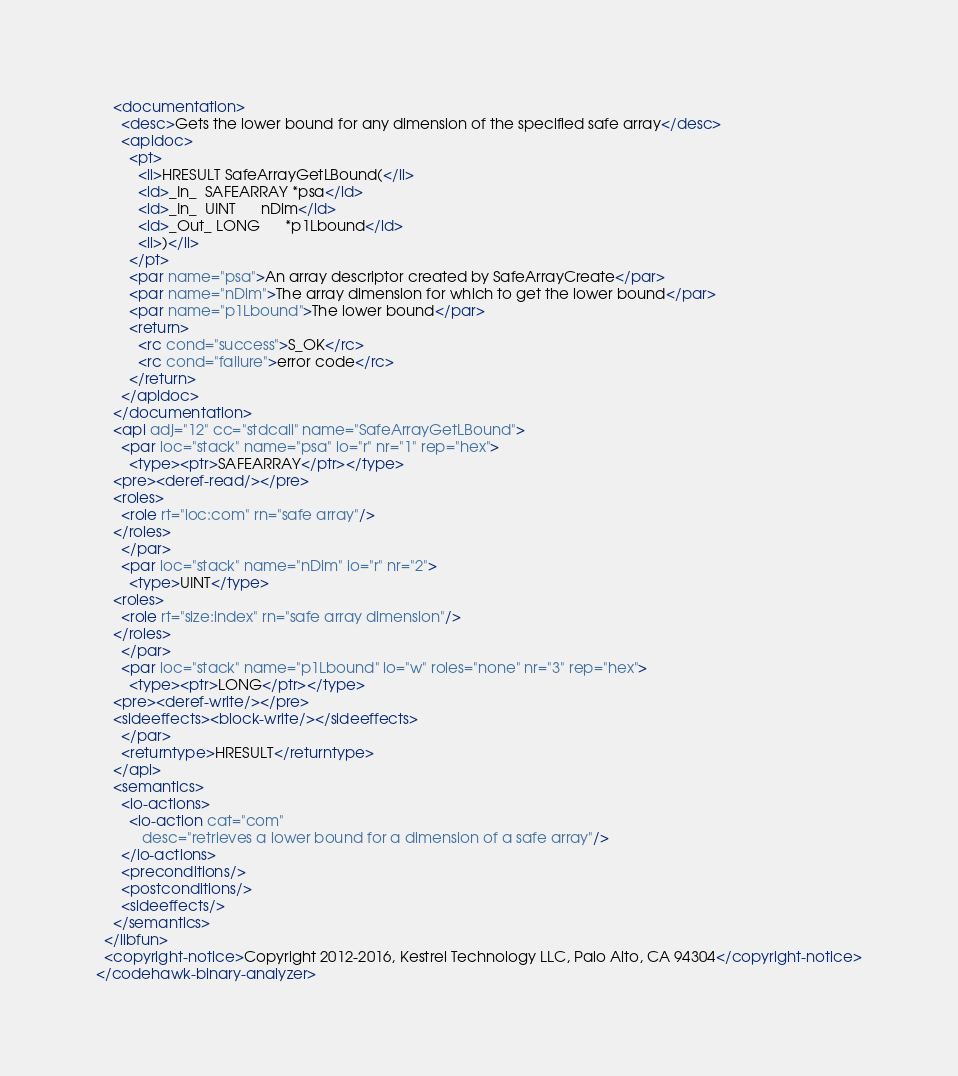Convert code to text. <code><loc_0><loc_0><loc_500><loc_500><_XML_>    <documentation>
      <desc>Gets the lower bound for any dimension of the specified safe array</desc>
      <apidoc>
        <pt>
          <ll>HRESULT SafeArrayGetLBound(</ll>
          <ld>_In_  SAFEARRAY *psa</ld>
          <ld>_In_  UINT      nDim</ld>
          <ld>_Out_ LONG      *p1Lbound</ld>
          <ll>)</ll>
        </pt>
        <par name="psa">An array descriptor created by SafeArrayCreate</par>
        <par name="nDim">The array dimension for which to get the lower bound</par>
        <par name="p1Lbound">The lower bound</par>
        <return>
          <rc cond="success">S_OK</rc>
          <rc cond="failure">error code</rc>
        </return>
      </apidoc>
    </documentation>
    <api adj="12" cc="stdcall" name="SafeArrayGetLBound">
      <par loc="stack" name="psa" io="r" nr="1" rep="hex">
        <type><ptr>SAFEARRAY</ptr></type>
	<pre><deref-read/></pre>
	<roles>
	  <role rt="ioc:com" rn="safe array"/>
	</roles>
      </par>
      <par loc="stack" name="nDim" io="r" nr="2">
        <type>UINT</type>
	<roles>
	  <role rt="size:index" rn="safe array dimension"/>
	</roles>
      </par>
      <par loc="stack" name="p1Lbound" io="w" roles="none" nr="3" rep="hex">
        <type><ptr>LONG</ptr></type>
	<pre><deref-write/></pre>
	<sideeffects><block-write/></sideeffects>
      </par>
      <returntype>HRESULT</returntype>
    </api>
    <semantics>
      <io-actions>
        <io-action cat="com"
		   desc="retrieves a lower bound for a dimension of a safe array"/>
      </io-actions>
      <preconditions/>
      <postconditions/>
      <sideeffects/>
    </semantics>
  </libfun>
  <copyright-notice>Copyright 2012-2016, Kestrel Technology LLC, Palo Alto, CA 94304</copyright-notice>
</codehawk-binary-analyzer>
</code> 